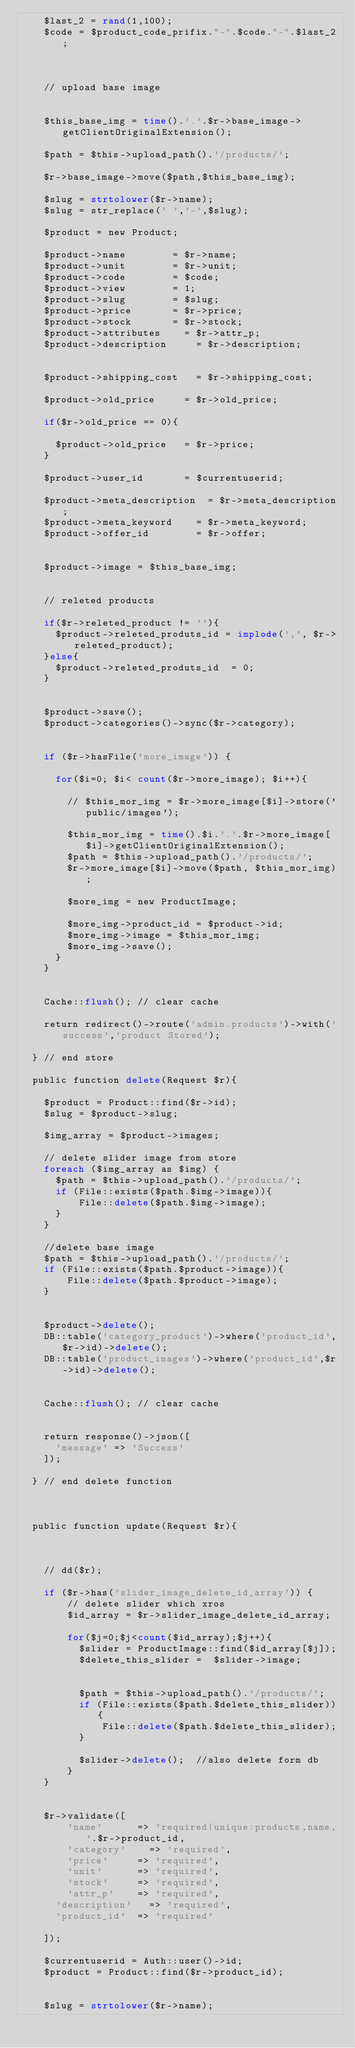Convert code to text. <code><loc_0><loc_0><loc_500><loc_500><_PHP_>		$last_2 = rand(1,100);
		$code = $product_code_prifix."-".$code."-".$last_2;
		


		// upload base image 
		

		$this_base_img = time().'.'.$r->base_image->getClientOriginalExtension();

		$path = $this->upload_path().'/products/';

		$r->base_image->move($path,$this_base_img);
		
		$slug = strtolower($r->name);
		$slug = str_replace(' ','-',$slug);

		$product = new Product;

		$product->name 				= $r->name;
		$product->unit 				= $r->unit;
		$product->code 				= $code;
		$product->view 				= 1;
		$product->slug 				= $slug;
		$product->price 			= $r->price;
		$product->stock 			= $r->stock;
		$product->attributes 		= $r->attr_p;
		$product->description 		= $r->description;


		$product->shipping_cost 	= $r->shipping_cost;

		$product->old_price 		= $r->old_price;

		if($r->old_price == 0){

			$product->old_price 	= $r->price;
		}

		$product->user_id 			= $currentuserid;

		$product->meta_description 	= $r->meta_description;
		$product->meta_keyword 		= $r->meta_keyword;
		$product->offer_id    		= $r->offer;
		
	
		$product->image = $this_base_img;


		// releted products

		if($r->releted_product != ''){
			$product->releted_produts_id = implode(',', $r->releted_product);
		}else{
			$product->releted_produts_id  = 0;
		}


		$product->save();
		$product->categories()->sync($r->category);

		
		if ($r->hasFile('more_image')) {

			for($i=0; $i< count($r->more_image); $i++){

				// $this_mor_img = $r->more_image[$i]->store('public/images');

				$this_mor_img = time().$i.'.'.$r->more_image[$i]->getClientOriginalExtension();
				$path = $this->upload_path().'/products/';
				$r->more_image[$i]->move($path, $this_mor_img);

				$more_img = new ProductImage;
				
				$more_img->product_id = $product->id;
				$more_img->image = $this_mor_img;
				$more_img->save();
			}
		}


		Cache::flush(); // clear cache

		return redirect()->route('admin.products')->with('success','product Stored'); 

	} // end store

	public function delete(Request $r){
		
		$product = Product::find($r->id);
		$slug = $product->slug;

		$img_array = $product->images;

		// delete slider image from store
		foreach ($img_array as $img) {
			$path = $this->upload_path().'/products/';
			if (File::exists($path.$img->image)){
			    File::delete($path.$img->image);
			}
		}
		
		//delete base image
		$path = $this->upload_path().'/products/';
		if (File::exists($path.$product->image)){
		    File::delete($path.$product->image);
		}


		$product->delete();
		DB::table('category_product')->where('product_id',$r->id)->delete();
		DB::table('product_images')->where('product_id',$r->id)->delete();
		

		Cache::flush(); // clear cache


		return response()->json([
			'message' => 'Success'
		]);

	} // end delete function 



	public function update(Request $r){



		// dd($r);

		if ($r->has('slider_image_delete_id_array')) {
   			// delete slider which xros
   			$id_array = $r->slider_image_delete_id_array;

   			for($j=0;$j<count($id_array);$j++){
   				$slider = ProductImage::find($id_array[$j]);
   				$delete_this_slider =  $slider->image;


   				$path = $this->upload_path().'/products/';
   				if (File::exists($path.$delete_this_slider)){
   				    File::delete($path.$delete_this_slider);
   				}

   				$slider->delete();  //also delete form db
   			}
		}

	
		$r->validate([
		    'name' 			=> 'required|unique:products,name,'.$r->product_id,
		    'category' 		=> 'required',
		    'price' 		=> 'required',
		    'unit' 			=> 'required',
		    'stock' 		=> 'required',
		    'attr_p' 		=> 'required',
			'description' 	=> 'required',
			'product_id' 	=> 'required'
			
		]);

		$currentuserid = Auth::user()->id;
		$product = Product::find($r->product_id);


		$slug = strtolower($r->name);</code> 